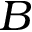<formula> <loc_0><loc_0><loc_500><loc_500>B</formula> 